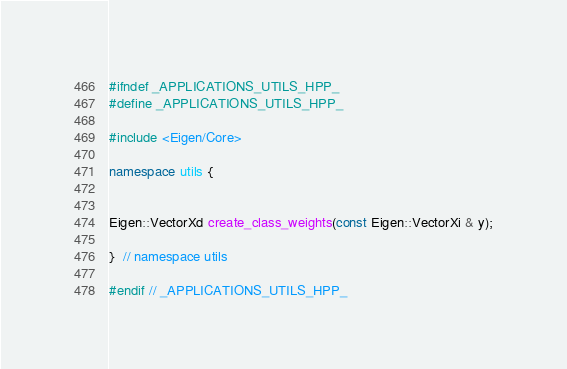Convert code to text. <code><loc_0><loc_0><loc_500><loc_500><_C++_>#ifndef _APPLICATIONS_UTILS_HPP_
#define _APPLICATIONS_UTILS_HPP_

#include <Eigen/Core>

namespace utils {


Eigen::VectorXd create_class_weights(const Eigen::VectorXi & y);

}  // namespace utils

#endif // _APPLICATIONS_UTILS_HPP_
</code> 